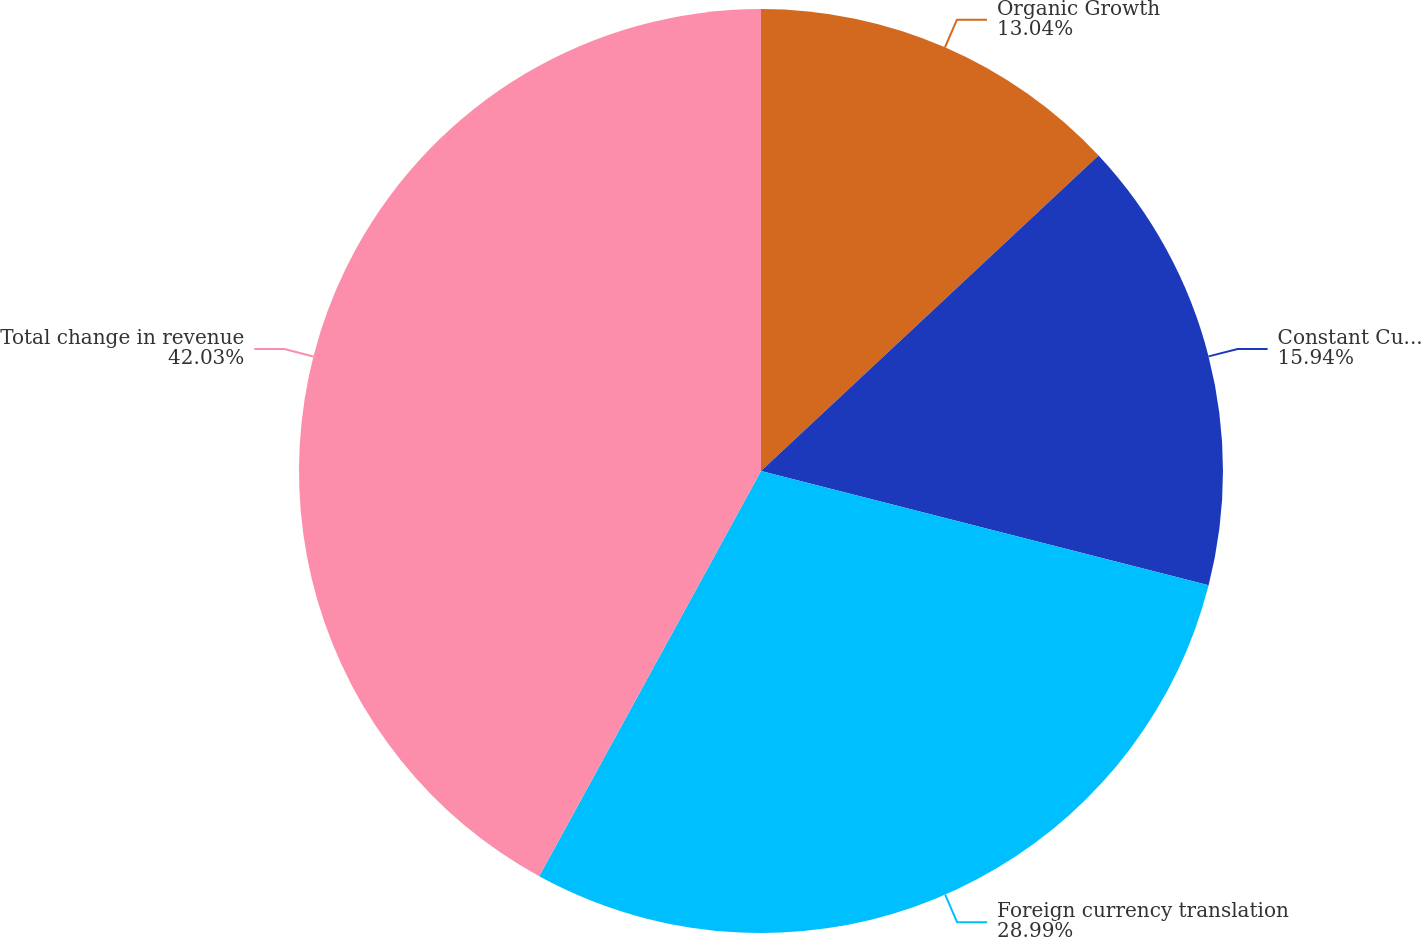Convert chart to OTSL. <chart><loc_0><loc_0><loc_500><loc_500><pie_chart><fcel>Organic Growth<fcel>Constant Currency<fcel>Foreign currency translation<fcel>Total change in revenue<nl><fcel>13.04%<fcel>15.94%<fcel>28.99%<fcel>42.03%<nl></chart> 